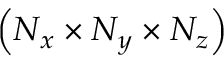Convert formula to latex. <formula><loc_0><loc_0><loc_500><loc_500>\left ( N _ { x } \times N _ { y } \times N _ { z } \right )</formula> 